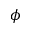<formula> <loc_0><loc_0><loc_500><loc_500>\phi</formula> 